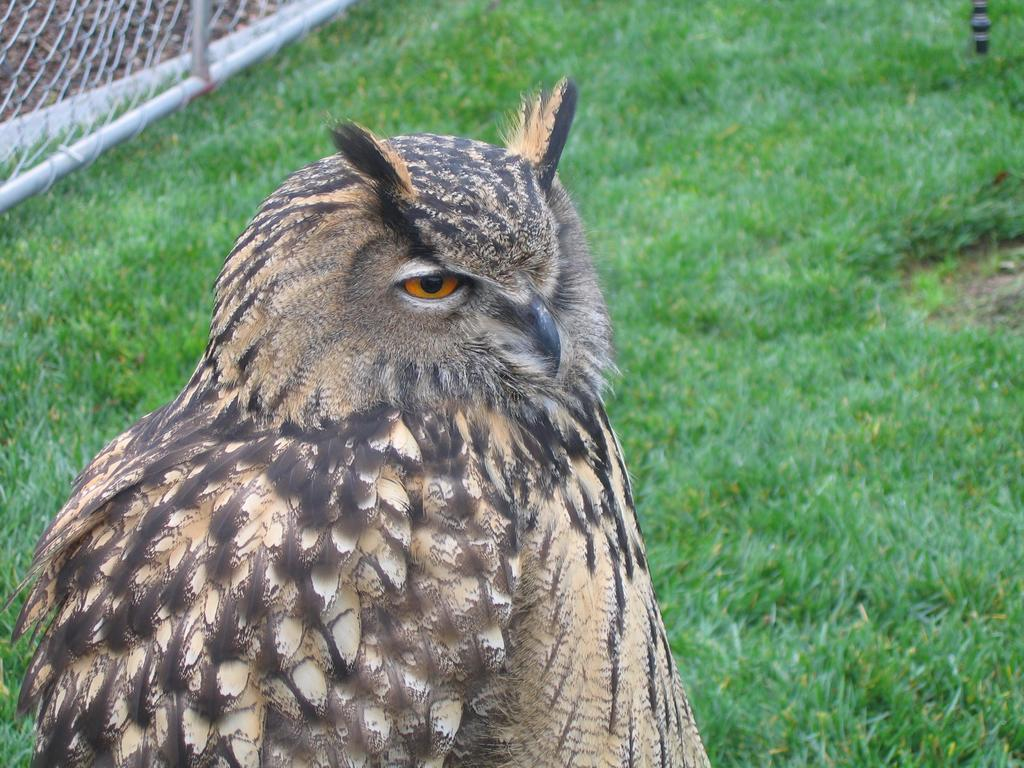What animal is in the picture? There is an owl in the picture. What type of environment is the owl in? There is grass behind the owl. What is behind the grass in the picture? There is wire fencing behind the owl. What type of milk is the owl attempting to cover in the picture? There is no milk present in the image, and the owl is not attempting to cover anything. 